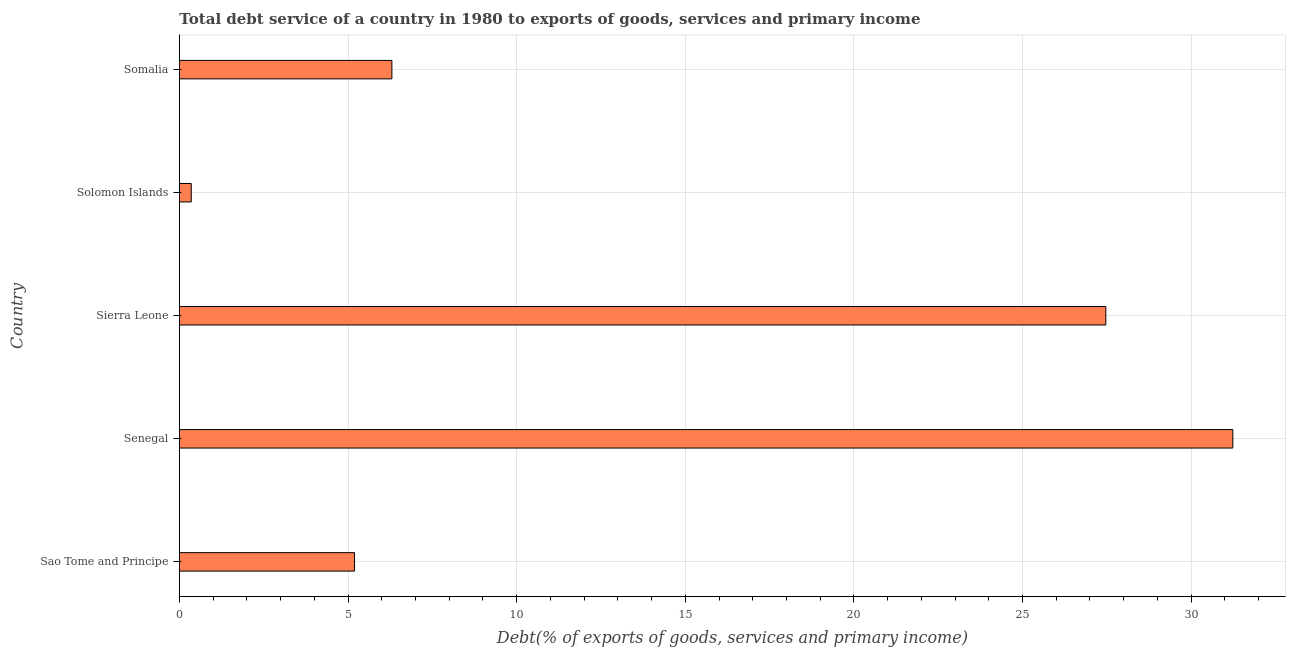Does the graph contain grids?
Your answer should be compact. Yes. What is the title of the graph?
Offer a terse response. Total debt service of a country in 1980 to exports of goods, services and primary income. What is the label or title of the X-axis?
Your answer should be very brief. Debt(% of exports of goods, services and primary income). What is the label or title of the Y-axis?
Your answer should be compact. Country. What is the total debt service in Sierra Leone?
Your answer should be very brief. 27.47. Across all countries, what is the maximum total debt service?
Give a very brief answer. 31.24. Across all countries, what is the minimum total debt service?
Make the answer very short. 0.35. In which country was the total debt service maximum?
Provide a succinct answer. Senegal. In which country was the total debt service minimum?
Your answer should be compact. Solomon Islands. What is the sum of the total debt service?
Your answer should be compact. 70.55. What is the difference between the total debt service in Senegal and Solomon Islands?
Make the answer very short. 30.88. What is the average total debt service per country?
Provide a short and direct response. 14.11. What is the median total debt service?
Make the answer very short. 6.3. In how many countries, is the total debt service greater than 15 %?
Your answer should be compact. 2. What is the ratio of the total debt service in Sao Tome and Principe to that in Sierra Leone?
Give a very brief answer. 0.19. Is the total debt service in Sao Tome and Principe less than that in Somalia?
Offer a terse response. Yes. What is the difference between the highest and the second highest total debt service?
Keep it short and to the point. 3.77. Is the sum of the total debt service in Sao Tome and Principe and Sierra Leone greater than the maximum total debt service across all countries?
Provide a succinct answer. Yes. What is the difference between the highest and the lowest total debt service?
Your answer should be compact. 30.88. Are all the bars in the graph horizontal?
Your answer should be very brief. Yes. How many countries are there in the graph?
Your response must be concise. 5. What is the difference between two consecutive major ticks on the X-axis?
Ensure brevity in your answer.  5. What is the Debt(% of exports of goods, services and primary income) of Sao Tome and Principe?
Ensure brevity in your answer.  5.19. What is the Debt(% of exports of goods, services and primary income) in Senegal?
Provide a short and direct response. 31.24. What is the Debt(% of exports of goods, services and primary income) of Sierra Leone?
Offer a terse response. 27.47. What is the Debt(% of exports of goods, services and primary income) in Solomon Islands?
Make the answer very short. 0.35. What is the Debt(% of exports of goods, services and primary income) of Somalia?
Your answer should be compact. 6.3. What is the difference between the Debt(% of exports of goods, services and primary income) in Sao Tome and Principe and Senegal?
Make the answer very short. -26.04. What is the difference between the Debt(% of exports of goods, services and primary income) in Sao Tome and Principe and Sierra Leone?
Provide a succinct answer. -22.28. What is the difference between the Debt(% of exports of goods, services and primary income) in Sao Tome and Principe and Solomon Islands?
Offer a terse response. 4.84. What is the difference between the Debt(% of exports of goods, services and primary income) in Sao Tome and Principe and Somalia?
Your answer should be very brief. -1.11. What is the difference between the Debt(% of exports of goods, services and primary income) in Senegal and Sierra Leone?
Keep it short and to the point. 3.77. What is the difference between the Debt(% of exports of goods, services and primary income) in Senegal and Solomon Islands?
Give a very brief answer. 30.88. What is the difference between the Debt(% of exports of goods, services and primary income) in Senegal and Somalia?
Your response must be concise. 24.93. What is the difference between the Debt(% of exports of goods, services and primary income) in Sierra Leone and Solomon Islands?
Provide a short and direct response. 27.12. What is the difference between the Debt(% of exports of goods, services and primary income) in Sierra Leone and Somalia?
Offer a very short reply. 21.17. What is the difference between the Debt(% of exports of goods, services and primary income) in Solomon Islands and Somalia?
Ensure brevity in your answer.  -5.95. What is the ratio of the Debt(% of exports of goods, services and primary income) in Sao Tome and Principe to that in Senegal?
Make the answer very short. 0.17. What is the ratio of the Debt(% of exports of goods, services and primary income) in Sao Tome and Principe to that in Sierra Leone?
Offer a very short reply. 0.19. What is the ratio of the Debt(% of exports of goods, services and primary income) in Sao Tome and Principe to that in Solomon Islands?
Provide a short and direct response. 14.8. What is the ratio of the Debt(% of exports of goods, services and primary income) in Sao Tome and Principe to that in Somalia?
Provide a short and direct response. 0.82. What is the ratio of the Debt(% of exports of goods, services and primary income) in Senegal to that in Sierra Leone?
Offer a very short reply. 1.14. What is the ratio of the Debt(% of exports of goods, services and primary income) in Senegal to that in Solomon Islands?
Keep it short and to the point. 89.05. What is the ratio of the Debt(% of exports of goods, services and primary income) in Senegal to that in Somalia?
Offer a very short reply. 4.96. What is the ratio of the Debt(% of exports of goods, services and primary income) in Sierra Leone to that in Solomon Islands?
Offer a very short reply. 78.31. What is the ratio of the Debt(% of exports of goods, services and primary income) in Sierra Leone to that in Somalia?
Your response must be concise. 4.36. What is the ratio of the Debt(% of exports of goods, services and primary income) in Solomon Islands to that in Somalia?
Provide a succinct answer. 0.06. 